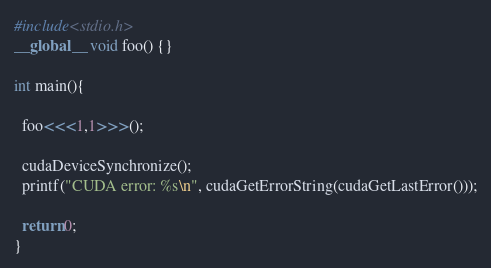Convert code to text. <code><loc_0><loc_0><loc_500><loc_500><_Cuda_>#include<stdio.h>
__global__ void foo() {}

int main(){
    
  foo<<<1,1>>>();

  cudaDeviceSynchronize();
  printf("CUDA error: %s\n", cudaGetErrorString(cudaGetLastError()));

  return 0;
}
</code> 